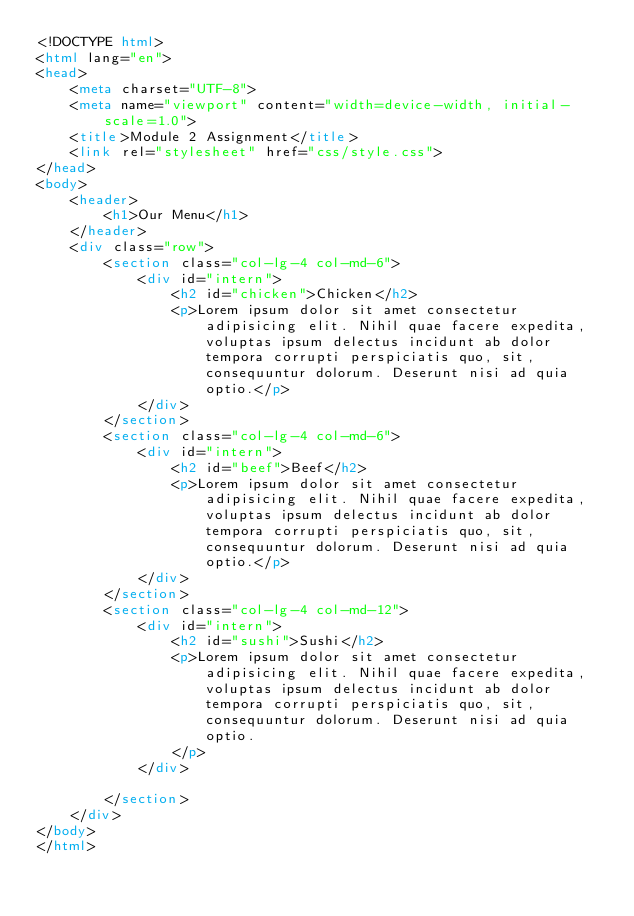<code> <loc_0><loc_0><loc_500><loc_500><_HTML_><!DOCTYPE html>
<html lang="en">
<head>
    <meta charset="UTF-8">
    <meta name="viewport" content="width=device-width, initial-scale=1.0">
    <title>Module 2 Assignment</title>
    <link rel="stylesheet" href="css/style.css">
</head>
<body>
    <header>
        <h1>Our Menu</h1>
    </header>
    <div class="row">
        <section class="col-lg-4 col-md-6">
            <div id="intern">
                <h2 id="chicken">Chicken</h2>
                <p>Lorem ipsum dolor sit amet consectetur adipisicing elit. Nihil quae facere expedita, voluptas ipsum delectus incidunt ab dolor tempora corrupti perspiciatis quo, sit, consequuntur dolorum. Deserunt nisi ad quia optio.</p>
            </div>
        </section>
        <section class="col-lg-4 col-md-6">
            <div id="intern">
                <h2 id="beef">Beef</h2>
                <p>Lorem ipsum dolor sit amet consectetur adipisicing elit. Nihil quae facere expedita, voluptas ipsum delectus incidunt ab dolor tempora corrupti perspiciatis quo, sit, consequuntur dolorum. Deserunt nisi ad quia optio.</p>
            </div>
        </section>
        <section class="col-lg-4 col-md-12">
            <div id="intern">
                <h2 id="sushi">Sushi</h2>
                <p>Lorem ipsum dolor sit amet consectetur adipisicing elit. Nihil quae facere expedita, voluptas ipsum delectus incidunt ab dolor tempora corrupti perspiciatis quo, sit, consequuntur dolorum. Deserunt nisi ad quia optio.
                </p>
            </div>

        </section>
    </div>
</body>
</html></code> 